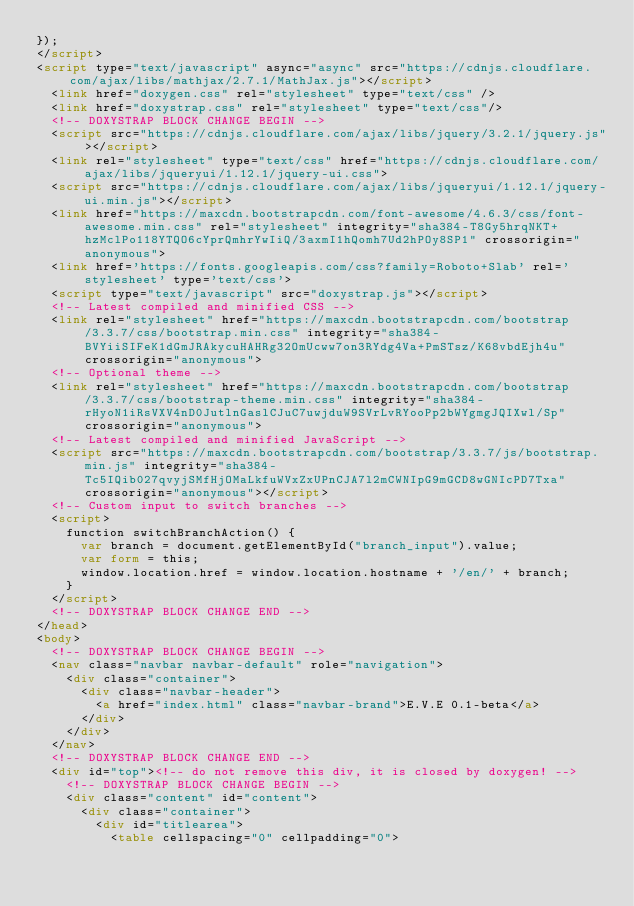<code> <loc_0><loc_0><loc_500><loc_500><_HTML_>});
</script>
<script type="text/javascript" async="async" src="https://cdnjs.cloudflare.com/ajax/libs/mathjax/2.7.1/MathJax.js"></script>
  <link href="doxygen.css" rel="stylesheet" type="text/css" />
  <link href="doxystrap.css" rel="stylesheet" type="text/css"/>
  <!-- DOXYSTRAP BLOCK CHANGE BEGIN -->
  <script src="https://cdnjs.cloudflare.com/ajax/libs/jquery/3.2.1/jquery.js"></script>
  <link rel="stylesheet" type="text/css" href="https://cdnjs.cloudflare.com/ajax/libs/jqueryui/1.12.1/jquery-ui.css">
  <script src="https://cdnjs.cloudflare.com/ajax/libs/jqueryui/1.12.1/jquery-ui.min.js"></script>
  <link href="https://maxcdn.bootstrapcdn.com/font-awesome/4.6.3/css/font-awesome.min.css" rel="stylesheet" integrity="sha384-T8Gy5hrqNKT+hzMclPo118YTQO6cYprQmhrYwIiQ/3axmI1hQomh7Ud2hPOy8SP1" crossorigin="anonymous">
  <link href='https://fonts.googleapis.com/css?family=Roboto+Slab' rel='stylesheet' type='text/css'>
  <script type="text/javascript" src="doxystrap.js"></script>
  <!-- Latest compiled and minified CSS -->
  <link rel="stylesheet" href="https://maxcdn.bootstrapcdn.com/bootstrap/3.3.7/css/bootstrap.min.css" integrity="sha384-BVYiiSIFeK1dGmJRAkycuHAHRg32OmUcww7on3RYdg4Va+PmSTsz/K68vbdEjh4u" crossorigin="anonymous">
  <!-- Optional theme -->
  <link rel="stylesheet" href="https://maxcdn.bootstrapcdn.com/bootstrap/3.3.7/css/bootstrap-theme.min.css" integrity="sha384-rHyoN1iRsVXV4nD0JutlnGaslCJuC7uwjduW9SVrLvRYooPp2bWYgmgJQIXwl/Sp" crossorigin="anonymous">
  <!-- Latest compiled and minified JavaScript -->
  <script src="https://maxcdn.bootstrapcdn.com/bootstrap/3.3.7/js/bootstrap.min.js" integrity="sha384-Tc5IQib027qvyjSMfHjOMaLkfuWVxZxUPnCJA7l2mCWNIpG9mGCD8wGNIcPD7Txa" crossorigin="anonymous"></script>
  <!-- Custom input to switch branches -->
  <script>
    function switchBranchAction() {
      var branch = document.getElementById("branch_input").value;
      var form = this;
      window.location.href = window.location.hostname + '/en/' + branch;
    }
  </script>
  <!-- DOXYSTRAP BLOCK CHANGE END -->
</head>
<body>
  <!-- DOXYSTRAP BLOCK CHANGE BEGIN -->
  <nav class="navbar navbar-default" role="navigation">
    <div class="container">
      <div class="navbar-header">
        <a href="index.html" class="navbar-brand">E.V.E 0.1-beta</a>
      </div>
    </div>
  </nav>
  <!-- DOXYSTRAP BLOCK CHANGE END -->
  <div id="top"><!-- do not remove this div, it is closed by doxygen! -->
    <!-- DOXYSTRAP BLOCK CHANGE BEGIN -->
    <div class="content" id="content">
      <div class="container">
        <div id="titlearea">
          <table cellspacing="0" cellpadding="0"></code> 